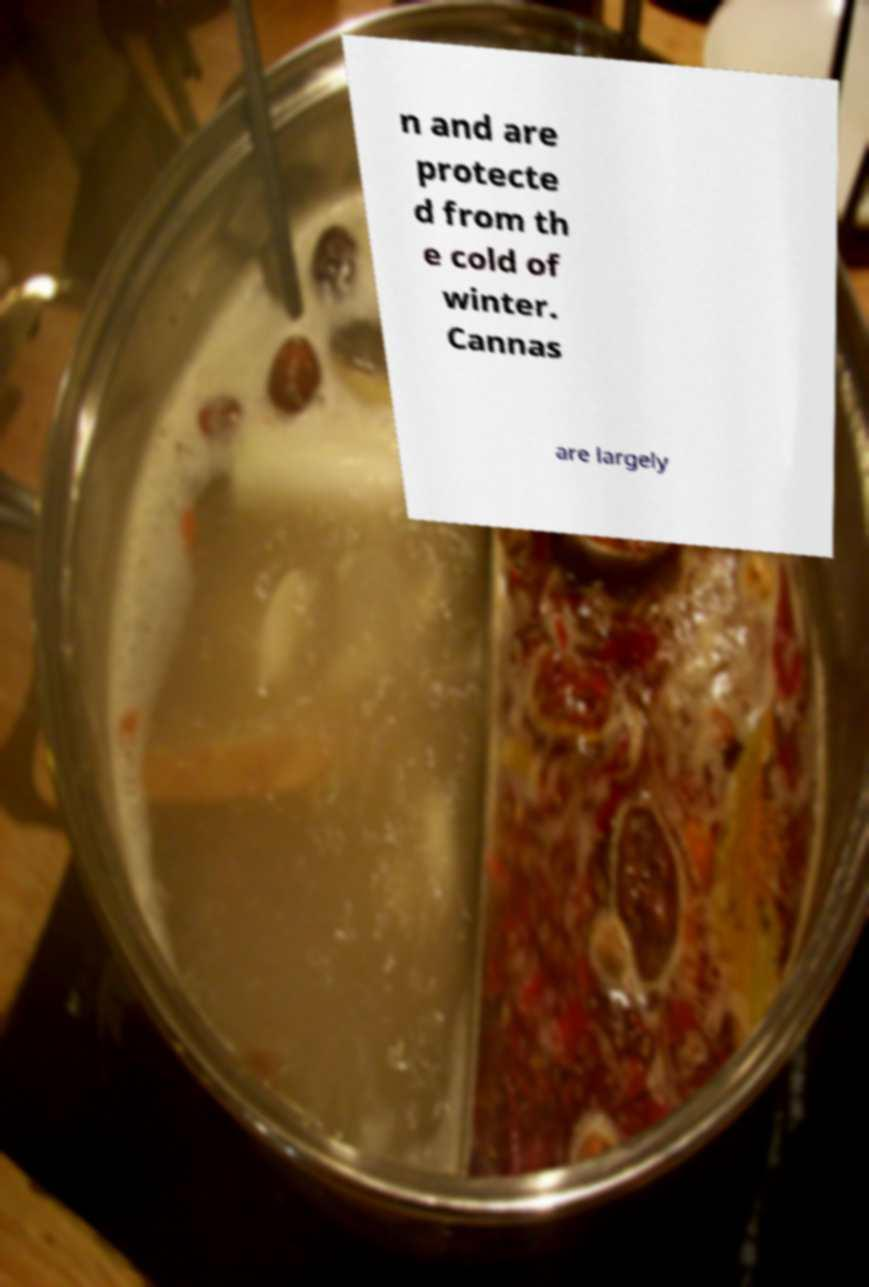Please read and relay the text visible in this image. What does it say? n and are protecte d from th e cold of winter. Cannas are largely 